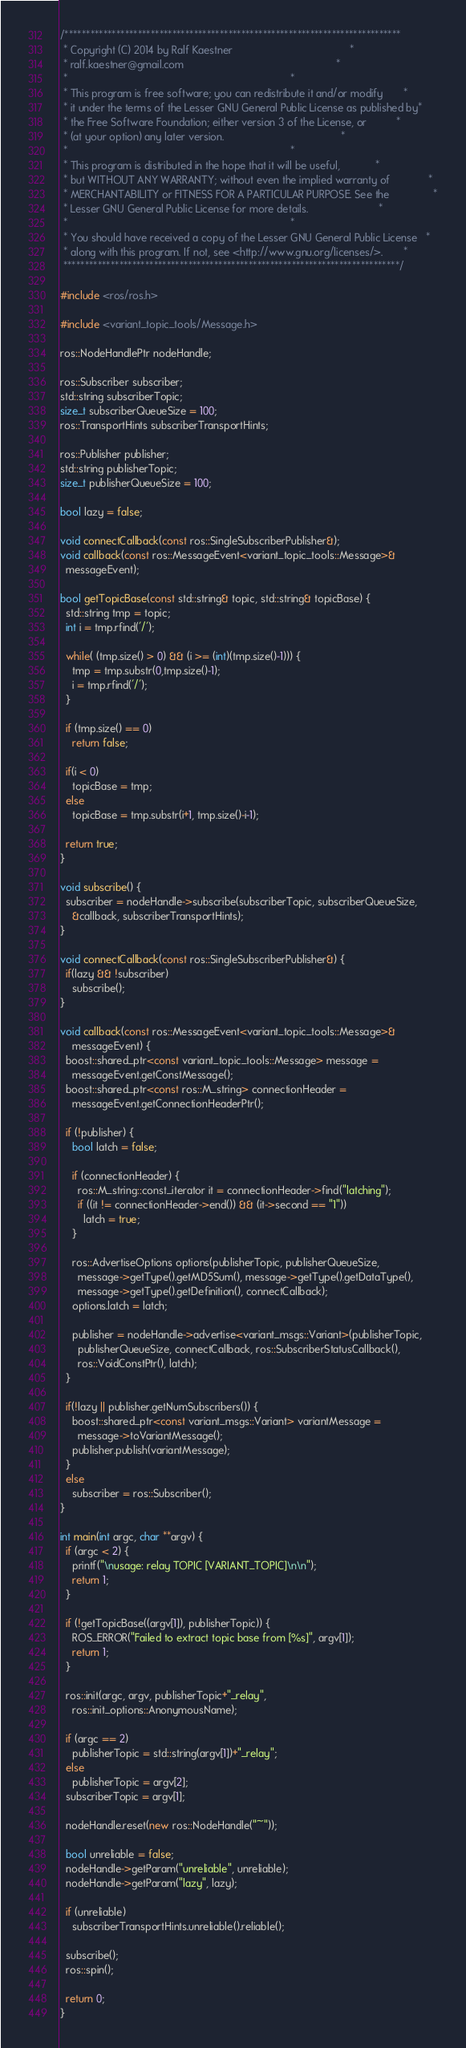<code> <loc_0><loc_0><loc_500><loc_500><_C++_>/******************************************************************************
 * Copyright (C) 2014 by Ralf Kaestner                                        *
 * ralf.kaestner@gmail.com                                                    *
 *                                                                            *
 * This program is free software; you can redistribute it and/or modify       *
 * it under the terms of the Lesser GNU General Public License as published by*
 * the Free Software Foundation; either version 3 of the License, or          *
 * (at your option) any later version.                                        *
 *                                                                            *
 * This program is distributed in the hope that it will be useful,            *
 * but WITHOUT ANY WARRANTY; without even the implied warranty of             *
 * MERCHANTABILITY or FITNESS FOR A PARTICULAR PURPOSE. See the               *
 * Lesser GNU General Public License for more details.                        *
 *                                                                            *
 * You should have received a copy of the Lesser GNU General Public License   *
 * along with this program. If not, see <http://www.gnu.org/licenses/>.       *
 ******************************************************************************/

#include <ros/ros.h>

#include <variant_topic_tools/Message.h>

ros::NodeHandlePtr nodeHandle;

ros::Subscriber subscriber;
std::string subscriberTopic;
size_t subscriberQueueSize = 100;
ros::TransportHints subscriberTransportHints;

ros::Publisher publisher;
std::string publisherTopic;
size_t publisherQueueSize = 100;

bool lazy = false;

void connectCallback(const ros::SingleSubscriberPublisher&);
void callback(const ros::MessageEvent<variant_topic_tools::Message>&
  messageEvent);

bool getTopicBase(const std::string& topic, std::string& topicBase) {
  std::string tmp = topic;
  int i = tmp.rfind('/');

  while( (tmp.size() > 0) && (i >= (int)(tmp.size()-1))) {
    tmp = tmp.substr(0,tmp.size()-1);
    i = tmp.rfind('/');
  }

  if (tmp.size() == 0)
    return false;

  if(i < 0)
    topicBase = tmp;
  else
    topicBase = tmp.substr(i+1, tmp.size()-i-1);

  return true;
}

void subscribe() {
  subscriber = nodeHandle->subscribe(subscriberTopic, subscriberQueueSize,
    &callback, subscriberTransportHints);
}

void connectCallback(const ros::SingleSubscriberPublisher&) {
  if(lazy && !subscriber)
    subscribe();
}

void callback(const ros::MessageEvent<variant_topic_tools::Message>&
    messageEvent) {
  boost::shared_ptr<const variant_topic_tools::Message> message =
    messageEvent.getConstMessage();
  boost::shared_ptr<const ros::M_string> connectionHeader =
    messageEvent.getConnectionHeaderPtr();

  if (!publisher) {
    bool latch = false;
    
    if (connectionHeader) {
      ros::M_string::const_iterator it = connectionHeader->find("latching");
      if ((it != connectionHeader->end()) && (it->second == "1"))
        latch = true;
    }
    
    ros::AdvertiseOptions options(publisherTopic, publisherQueueSize,
      message->getType().getMD5Sum(), message->getType().getDataType(),
      message->getType().getDefinition(), connectCallback);
    options.latch = latch;
    
    publisher = nodeHandle->advertise<variant_msgs::Variant>(publisherTopic,
      publisherQueueSize, connectCallback, ros::SubscriberStatusCallback(),
      ros::VoidConstPtr(), latch);
  }

  if(!lazy || publisher.getNumSubscribers()) {
    boost::shared_ptr<const variant_msgs::Variant> variantMessage =
      message->toVariantMessage();
    publisher.publish(variantMessage);
  }
  else
    subscriber = ros::Subscriber();
}

int main(int argc, char **argv) {
  if (argc < 2) {
    printf("\nusage: relay TOPIC [VARIANT_TOPIC]\n\n");
    return 1;
  }
  
  if (!getTopicBase((argv[1]), publisherTopic)) {
    ROS_ERROR("Failed to extract topic base from [%s]", argv[1]);
    return 1;
  }
  
  ros::init(argc, argv, publisherTopic+"_relay",
    ros::init_options::AnonymousName);
  
  if (argc == 2)
    publisherTopic = std::string(argv[1])+"_relay";
  else
    publisherTopic = argv[2];
  subscriberTopic = argv[1];
  
  nodeHandle.reset(new ros::NodeHandle("~"));
 
  bool unreliable = false;
  nodeHandle->getParam("unreliable", unreliable);
  nodeHandle->getParam("lazy", lazy);

  if (unreliable)
    subscriberTransportHints.unreliable().reliable();

  subscribe();
  ros::spin();
  
  return 0;
}
</code> 